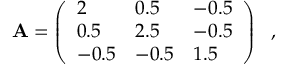Convert formula to latex. <formula><loc_0><loc_0><loc_500><loc_500>A = \left ( \begin{array} { l l l } { 2 } & { 0 . 5 } & { - 0 . 5 } \\ { 0 . 5 } & { 2 . 5 } & { - 0 . 5 } \\ { - 0 . 5 } & { - 0 . 5 } & { 1 . 5 } \end{array} \right ) \ ,</formula> 